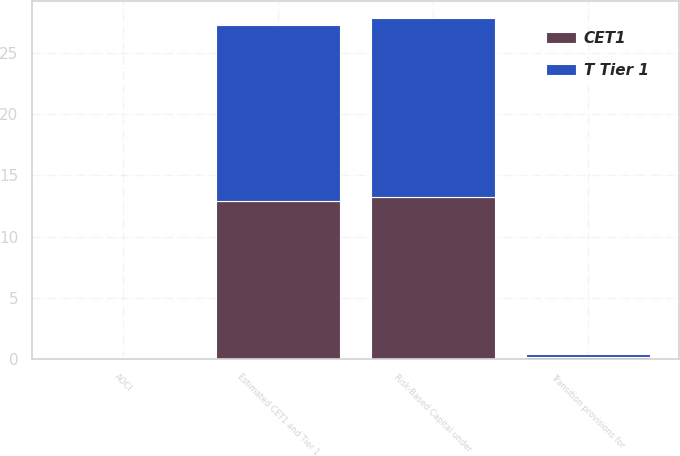Convert chart. <chart><loc_0><loc_0><loc_500><loc_500><stacked_bar_chart><ecel><fcel>Risk-Based Capital under<fcel>AOCI<fcel>Transition provisions for<fcel>Estimated CET1 and Tier 1<nl><fcel>CET1<fcel>13.2<fcel>0.1<fcel>0.2<fcel>12.9<nl><fcel>T Tier 1<fcel>14.7<fcel>0.1<fcel>0.2<fcel>14.4<nl></chart> 